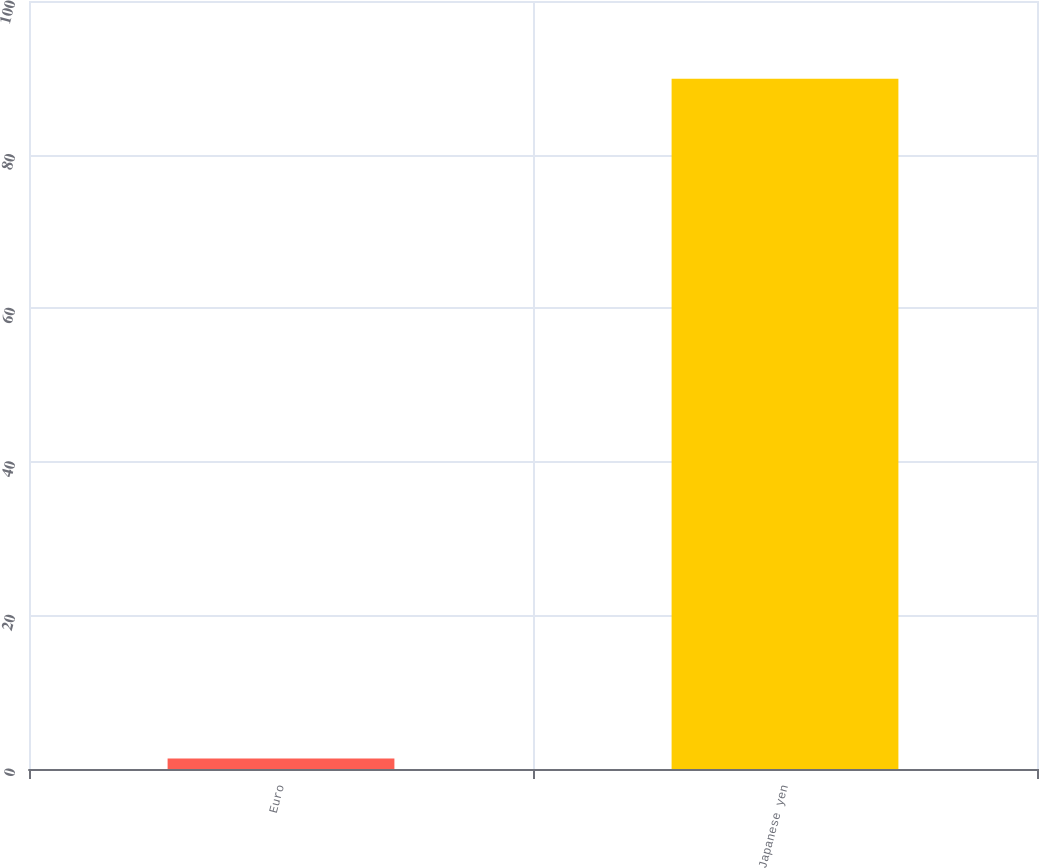Convert chart to OTSL. <chart><loc_0><loc_0><loc_500><loc_500><bar_chart><fcel>Euro<fcel>Japanese yen<nl><fcel>1.36<fcel>89.87<nl></chart> 